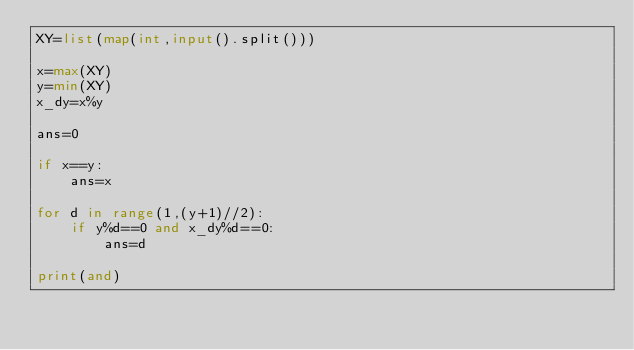<code> <loc_0><loc_0><loc_500><loc_500><_Python_>XY=list(map(int,input().split()))

x=max(XY)
y=min(XY)
x_dy=x%y

ans=0

if x==y:
    ans=x

for d in range(1,(y+1)//2):
    if y%d==0 and x_dy%d==0:
        ans=d

print(and)</code> 